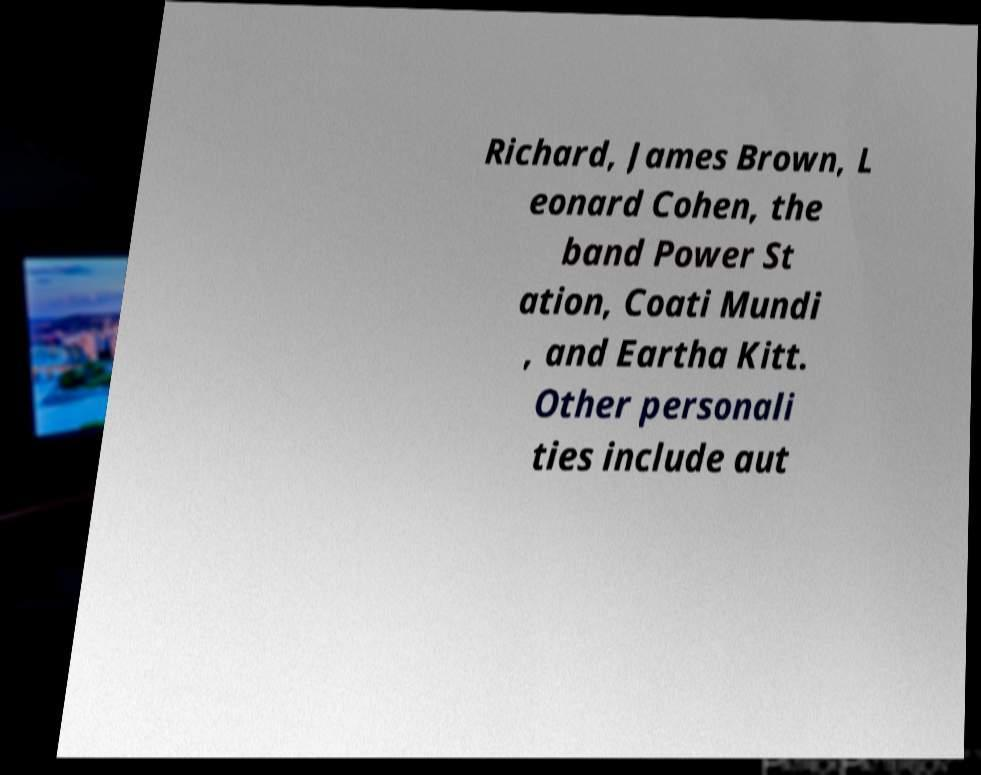Could you extract and type out the text from this image? Richard, James Brown, L eonard Cohen, the band Power St ation, Coati Mundi , and Eartha Kitt. Other personali ties include aut 